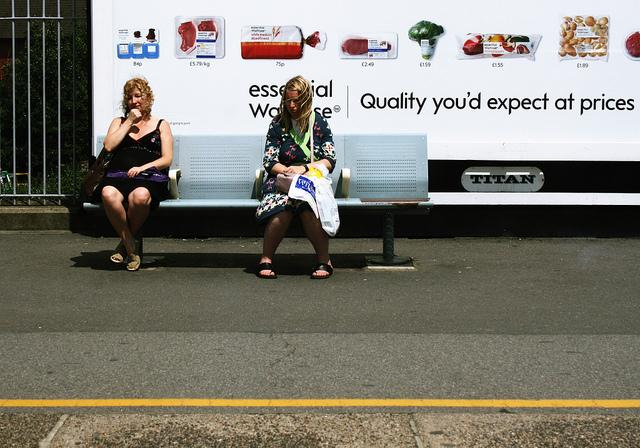What is the large object trying to get you to do? Please explain your reasoning. buy goods. The large object is advertising items for purchase at essential warehouse. 